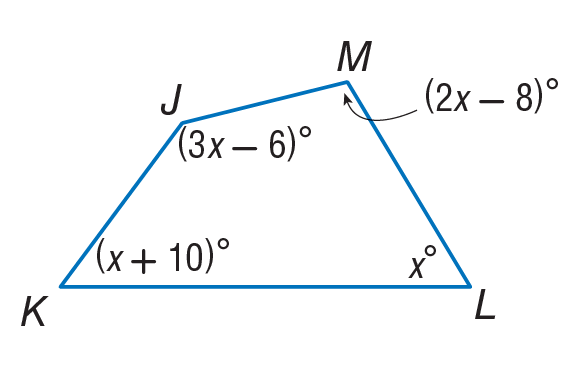Answer the mathemtical geometry problem and directly provide the correct option letter.
Question: Find m \angle L.
Choices: A: 52 B: 62 C: 96 D: 150 A 